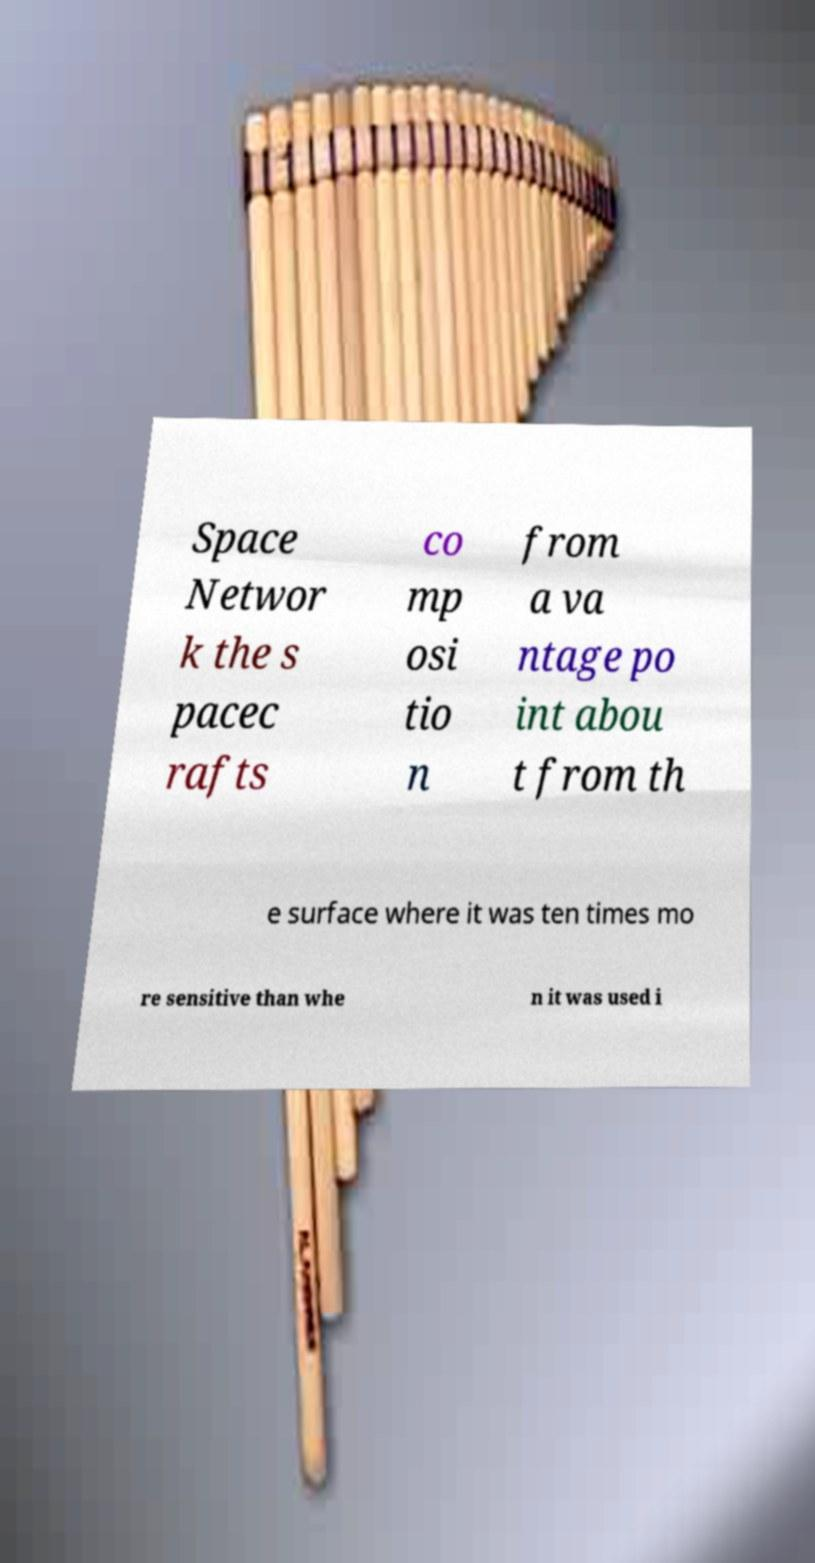Please read and relay the text visible in this image. What does it say? Space Networ k the s pacec rafts co mp osi tio n from a va ntage po int abou t from th e surface where it was ten times mo re sensitive than whe n it was used i 